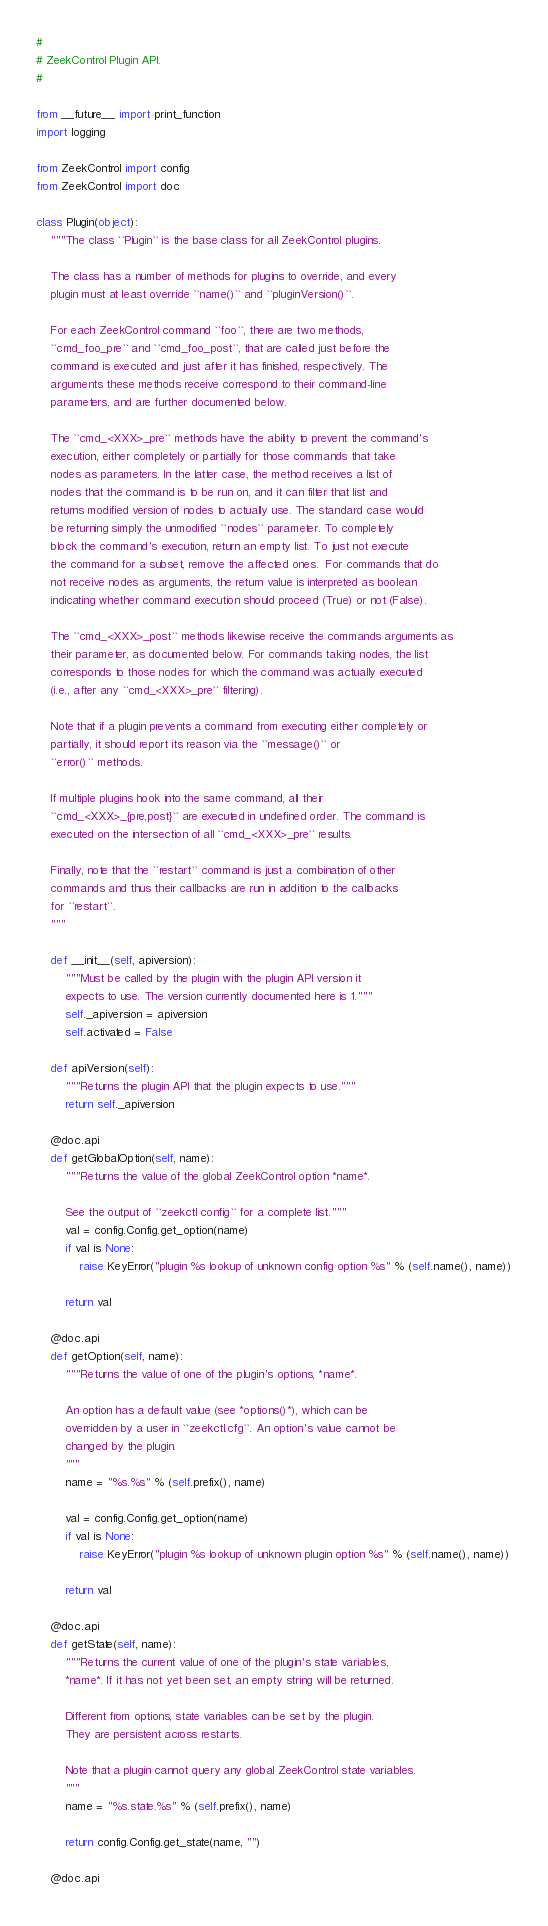<code> <loc_0><loc_0><loc_500><loc_500><_Python_>#
# ZeekControl Plugin API.
#

from __future__ import print_function
import logging

from ZeekControl import config
from ZeekControl import doc

class Plugin(object):
    """The class ``Plugin`` is the base class for all ZeekControl plugins.

    The class has a number of methods for plugins to override, and every
    plugin must at least override ``name()`` and ``pluginVersion()``.

    For each ZeekControl command ``foo``, there are two methods,
    ``cmd_foo_pre`` and ``cmd_foo_post``, that are called just before the
    command is executed and just after it has finished, respectively. The
    arguments these methods receive correspond to their command-line
    parameters, and are further documented below.

    The ``cmd_<XXX>_pre`` methods have the ability to prevent the command's
    execution, either completely or partially for those commands that take
    nodes as parameters. In the latter case, the method receives a list of
    nodes that the command is to be run on, and it can filter that list and
    returns modified version of nodes to actually use. The standard case would
    be returning simply the unmodified ``nodes`` parameter. To completely
    block the command's execution, return an empty list. To just not execute
    the command for a subset, remove the affected ones.  For commands that do
    not receive nodes as arguments, the return value is interpreted as boolean
    indicating whether command execution should proceed (True) or not (False).

    The ``cmd_<XXX>_post`` methods likewise receive the commands arguments as
    their parameter, as documented below. For commands taking nodes, the list
    corresponds to those nodes for which the command was actually executed
    (i.e., after any ``cmd_<XXX>_pre`` filtering).

    Note that if a plugin prevents a command from executing either completely or
    partially, it should report its reason via the ``message()`` or
    ``error()`` methods.

    If multiple plugins hook into the same command, all their
    ``cmd_<XXX>_{pre,post}`` are executed in undefined order. The command is
    executed on the intersection of all ``cmd_<XXX>_pre`` results.

    Finally, note that the ``restart`` command is just a combination of other
    commands and thus their callbacks are run in addition to the callbacks
    for ``restart``.
    """

    def __init__(self, apiversion):
        """Must be called by the plugin with the plugin API version it
        expects to use. The version currently documented here is 1."""
        self._apiversion = apiversion
        self.activated = False

    def apiVersion(self):
        """Returns the plugin API that the plugin expects to use."""
        return self._apiversion

    @doc.api
    def getGlobalOption(self, name):
        """Returns the value of the global ZeekControl option *name*.

        See the output of ``zeekctl config`` for a complete list."""
        val = config.Config.get_option(name)
        if val is None:
            raise KeyError("plugin %s lookup of unknown config option %s" % (self.name(), name))

        return val

    @doc.api
    def getOption(self, name):
        """Returns the value of one of the plugin's options, *name*.

        An option has a default value (see *options()*), which can be
        overridden by a user in ``zeekctl.cfg``. An option's value cannot be
        changed by the plugin.
        """
        name = "%s.%s" % (self.prefix(), name)

        val = config.Config.get_option(name)
        if val is None:
            raise KeyError("plugin %s lookup of unknown plugin option %s" % (self.name(), name))

        return val

    @doc.api
    def getState(self, name):
        """Returns the current value of one of the plugin's state variables,
        *name*. If it has not yet been set, an empty string will be returned.

        Different from options, state variables can be set by the plugin.
        They are persistent across restarts.

        Note that a plugin cannot query any global ZeekControl state variables.
        """
        name = "%s.state.%s" % (self.prefix(), name)

        return config.Config.get_state(name, "")

    @doc.api</code> 